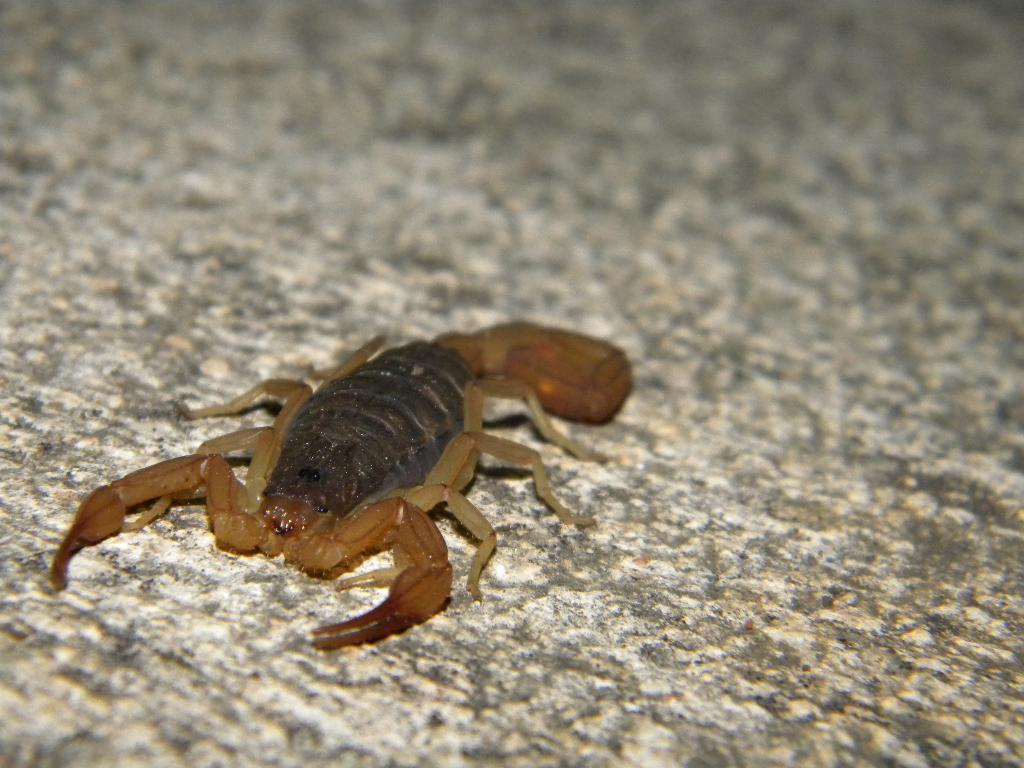Please provide a concise description of this image. In this picture we can see a scorpion. 